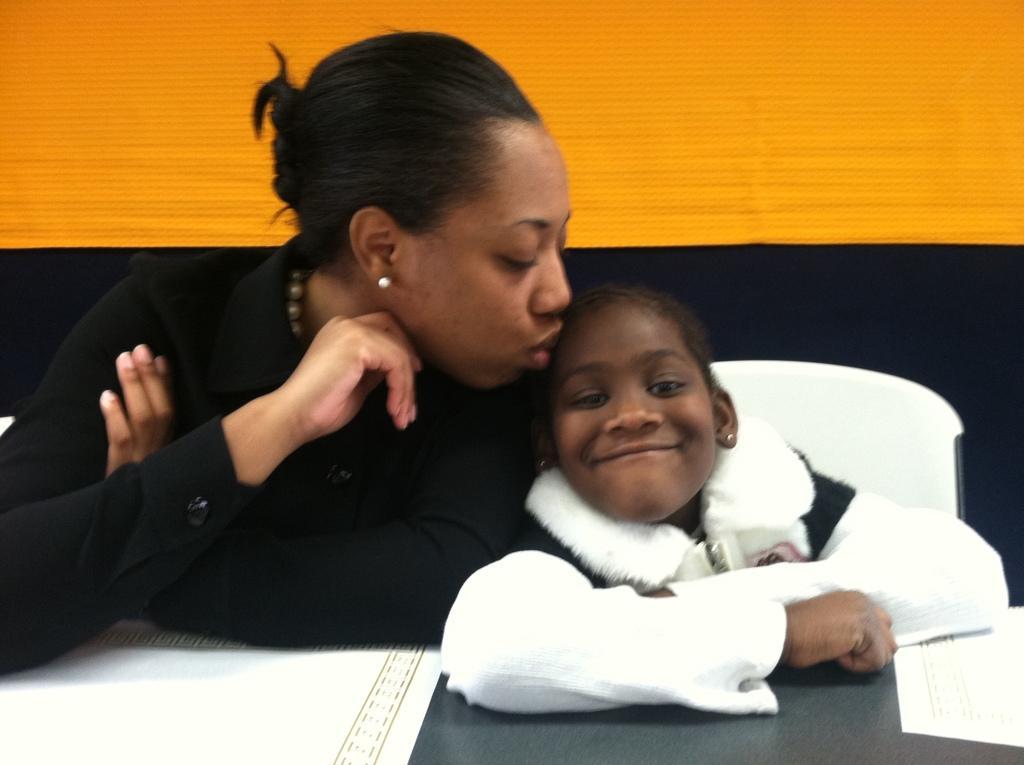Can you describe this image briefly? This is the woman and a girl sitting. I can see a woman kissing the girl. This is a table with the papers on it. I can see the wall, which is yellow and black in color. 